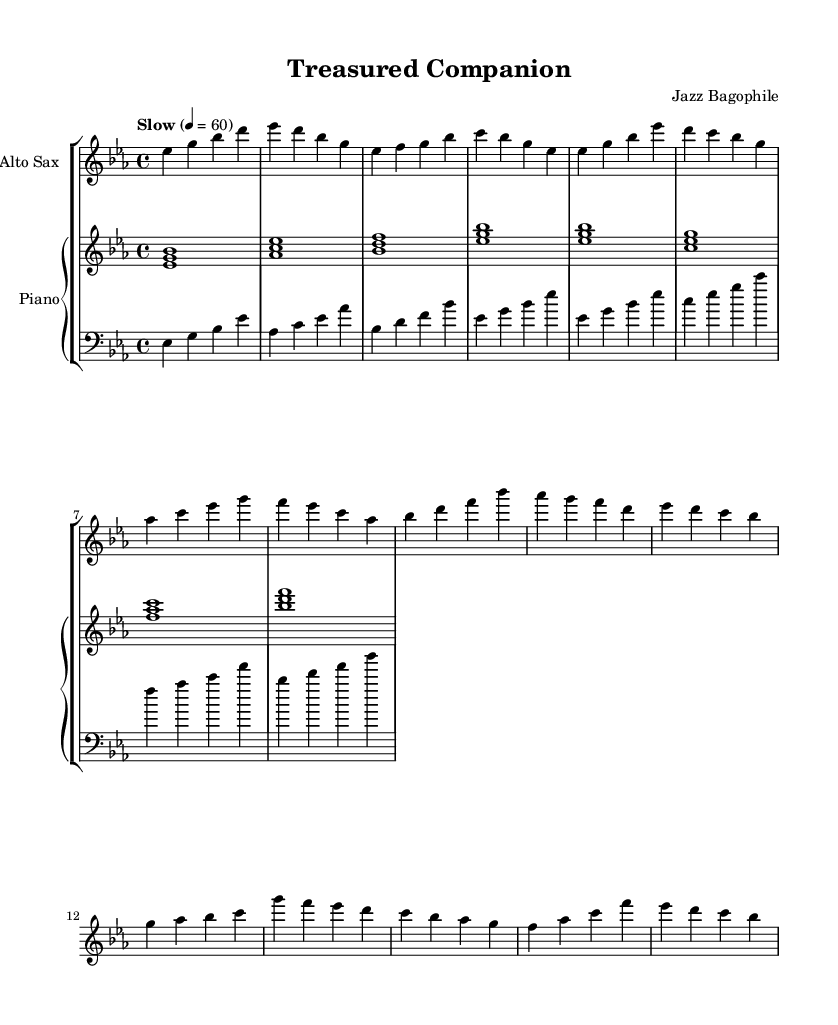What is the key signature of this music? The key signature indicates that this piece is in E-flat major, which has three flats: B flat, E flat, and A flat.
Answer: E-flat major What is the time signature of this music? The time signature, found at the beginning of the score, is four-four, which means there are four beats per measure, and the quarter note receives one beat.
Answer: 4/4 What is the tempo marking of this piece? The tempo marking indicates that this music should be played slowly at a quarter note equals sixty beats per minute, which is a relaxed and contemplative pace suitable for a romantic ballad.
Answer: Slow, 60 How many measures are in the A section? The A section contains eight measures, which can be counted directly from the notation provided in the saxophone and piano parts.
Answer: 8 What instrument plays the main melody? The main melody of this piece is played by the alto saxophone, as indicated by the notation on the staff specifically designated for the saxophone.
Answer: Alto Sax What chords are used in the intro? The intro features four chords: E flat major, A flat major, B flat major, and E flat major, as shown in the piano part where these chords are indicated by the stacked notes.
Answer: E flat, A flat, B flat, E flat In which section does the dynamic shift occur? The dynamic shift typically occurs in the B section, where the music may explore different emotional nuances, providing a contrast to the earlier A section. This can be noted by the change in the musical lines and possibly the notation for dynamics.
Answer: B section 